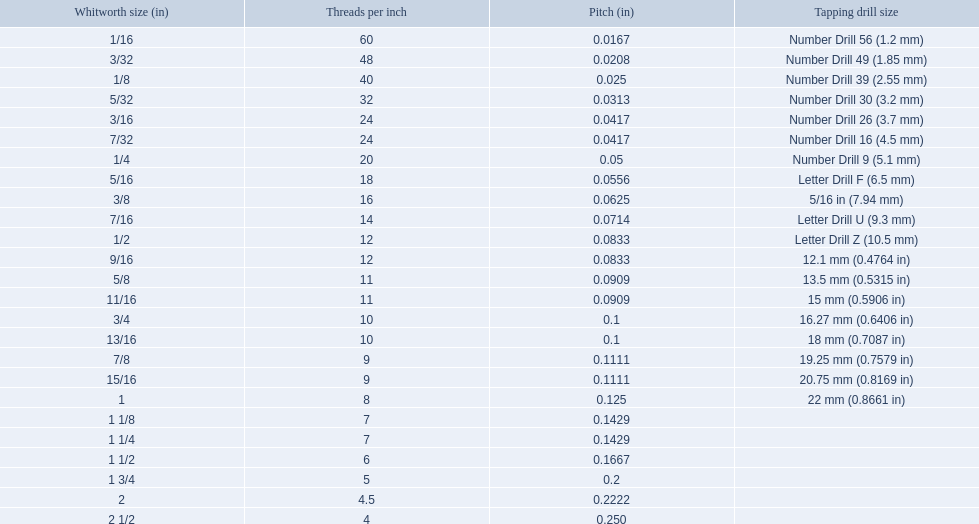A 1/16 whitworth has a core diameter of? 0.0411. Which whiteworth size has the same pitch as a 1/2? 9/16. 3/16 whiteworth has the same number of threads as? 7/32. What are all the whitworth sizes? 1/16, 3/32, 1/8, 5/32, 3/16, 7/32, 1/4, 5/16, 3/8, 7/16, 1/2, 9/16, 5/8, 11/16, 3/4, 13/16, 7/8, 15/16, 1, 1 1/8, 1 1/4, 1 1/2, 1 3/4, 2, 2 1/2. What are the threads per inch of these sizes? 60, 48, 40, 32, 24, 24, 20, 18, 16, 14, 12, 12, 11, 11, 10, 10, 9, 9, 8, 7, 7, 6, 5, 4.5, 4. Of these, which are 5? 5. What whitworth size has this threads per inch? 1 3/4. 